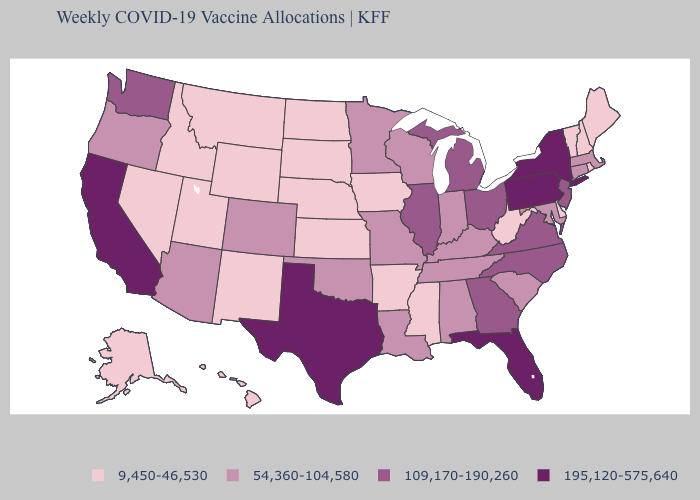What is the highest value in the Northeast ?
Keep it brief. 195,120-575,640. Which states have the lowest value in the MidWest?
Keep it brief. Iowa, Kansas, Nebraska, North Dakota, South Dakota. What is the value of Kansas?
Concise answer only. 9,450-46,530. Which states hav the highest value in the West?
Quick response, please. California. What is the value of New Jersey?
Write a very short answer. 109,170-190,260. Name the states that have a value in the range 109,170-190,260?
Give a very brief answer. Georgia, Illinois, Michigan, New Jersey, North Carolina, Ohio, Virginia, Washington. Which states hav the highest value in the MidWest?
Answer briefly. Illinois, Michigan, Ohio. What is the value of South Carolina?
Keep it brief. 54,360-104,580. What is the value of Hawaii?
Keep it brief. 9,450-46,530. Is the legend a continuous bar?
Quick response, please. No. Which states hav the highest value in the South?
Short answer required. Florida, Texas. Does Arkansas have the lowest value in the USA?
Give a very brief answer. Yes. What is the value of South Carolina?
Concise answer only. 54,360-104,580. What is the value of Idaho?
Write a very short answer. 9,450-46,530. Which states have the highest value in the USA?
Quick response, please. California, Florida, New York, Pennsylvania, Texas. 